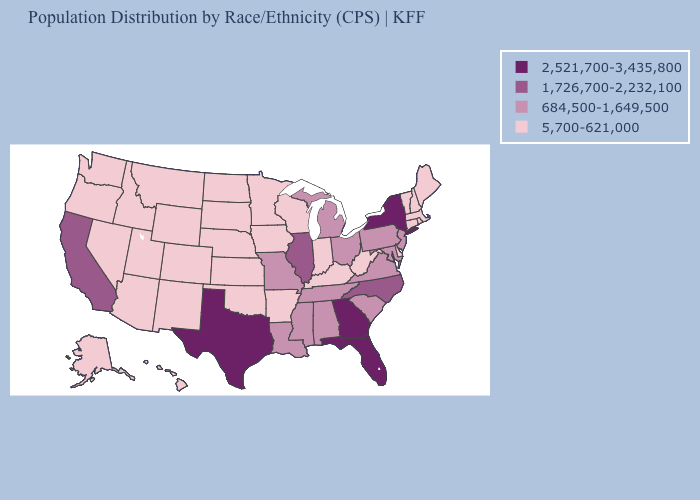Among the states that border Alabama , which have the lowest value?
Answer briefly. Mississippi, Tennessee. Name the states that have a value in the range 684,500-1,649,500?
Write a very short answer. Alabama, Louisiana, Maryland, Michigan, Mississippi, Missouri, New Jersey, Ohio, Pennsylvania, South Carolina, Tennessee, Virginia. How many symbols are there in the legend?
Be succinct. 4. Name the states that have a value in the range 5,700-621,000?
Answer briefly. Alaska, Arizona, Arkansas, Colorado, Connecticut, Delaware, Hawaii, Idaho, Indiana, Iowa, Kansas, Kentucky, Maine, Massachusetts, Minnesota, Montana, Nebraska, Nevada, New Hampshire, New Mexico, North Dakota, Oklahoma, Oregon, Rhode Island, South Dakota, Utah, Vermont, Washington, West Virginia, Wisconsin, Wyoming. Does Missouri have the highest value in the USA?
Quick response, please. No. Does Washington have the lowest value in the West?
Short answer required. Yes. Name the states that have a value in the range 5,700-621,000?
Be succinct. Alaska, Arizona, Arkansas, Colorado, Connecticut, Delaware, Hawaii, Idaho, Indiana, Iowa, Kansas, Kentucky, Maine, Massachusetts, Minnesota, Montana, Nebraska, Nevada, New Hampshire, New Mexico, North Dakota, Oklahoma, Oregon, Rhode Island, South Dakota, Utah, Vermont, Washington, West Virginia, Wisconsin, Wyoming. Among the states that border Nevada , which have the lowest value?
Short answer required. Arizona, Idaho, Oregon, Utah. Does Oklahoma have the lowest value in the South?
Concise answer only. Yes. What is the value of Arizona?
Answer briefly. 5,700-621,000. Name the states that have a value in the range 1,726,700-2,232,100?
Keep it brief. California, Illinois, North Carolina. Does the first symbol in the legend represent the smallest category?
Concise answer only. No. Does New Hampshire have the same value as Connecticut?
Keep it brief. Yes. Name the states that have a value in the range 1,726,700-2,232,100?
Keep it brief. California, Illinois, North Carolina. 